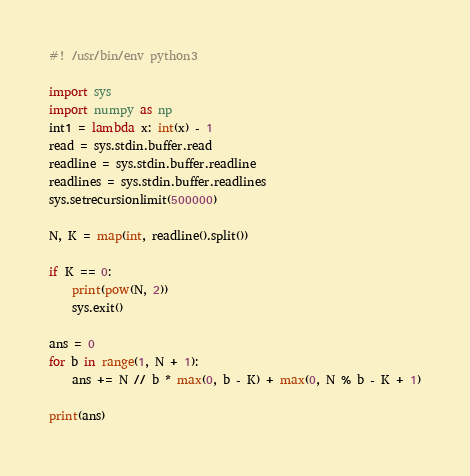Convert code to text. <code><loc_0><loc_0><loc_500><loc_500><_Python_>#! /usr/bin/env python3

import sys
import numpy as np
int1 = lambda x: int(x) - 1
read = sys.stdin.buffer.read
readline = sys.stdin.buffer.readline
readlines = sys.stdin.buffer.readlines
sys.setrecursionlimit(500000)

N, K = map(int, readline().split())

if K == 0:
    print(pow(N, 2))
    sys.exit()

ans = 0
for b in range(1, N + 1):
    ans += N // b * max(0, b - K) + max(0, N % b - K + 1)

print(ans)
</code> 